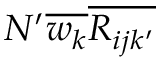Convert formula to latex. <formula><loc_0><loc_0><loc_500><loc_500>N ^ { \prime } \overline { { w _ { k } } } \overline { { R _ { i j k ^ { \prime } } } }</formula> 